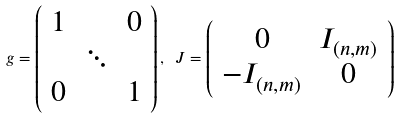<formula> <loc_0><loc_0><loc_500><loc_500>g = \left ( \begin{array} { c c c } 1 & & 0 \\ & \ddots & \\ 0 & & 1 \end{array} \right ) , \text { } J = \left ( \begin{array} { c c } 0 & I _ { ( n , m ) } \\ - I _ { ( n , m ) } & 0 \end{array} \right )</formula> 